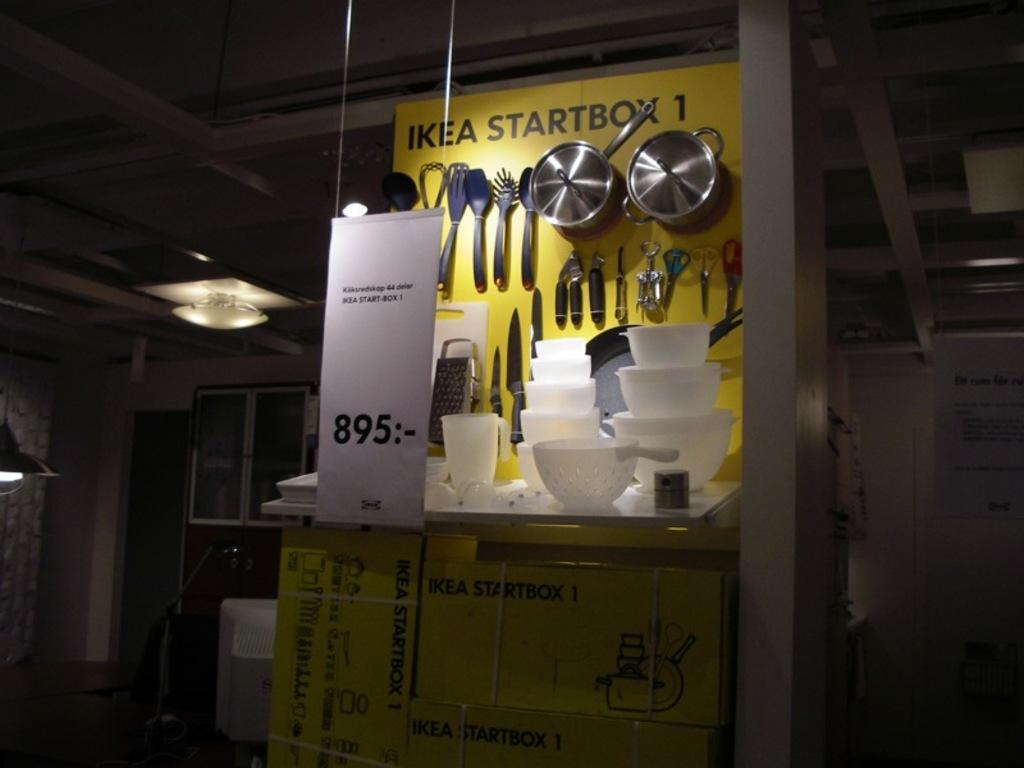What type of utensils can be seen on the desk in the image? The utensils on the desk include bowls and spoons. What else can be found on the desk in the image? There are other items on the desk besides the utensils. What is the temperature of the tooth on the desk in the image? There is no tooth present on the desk in the image. 